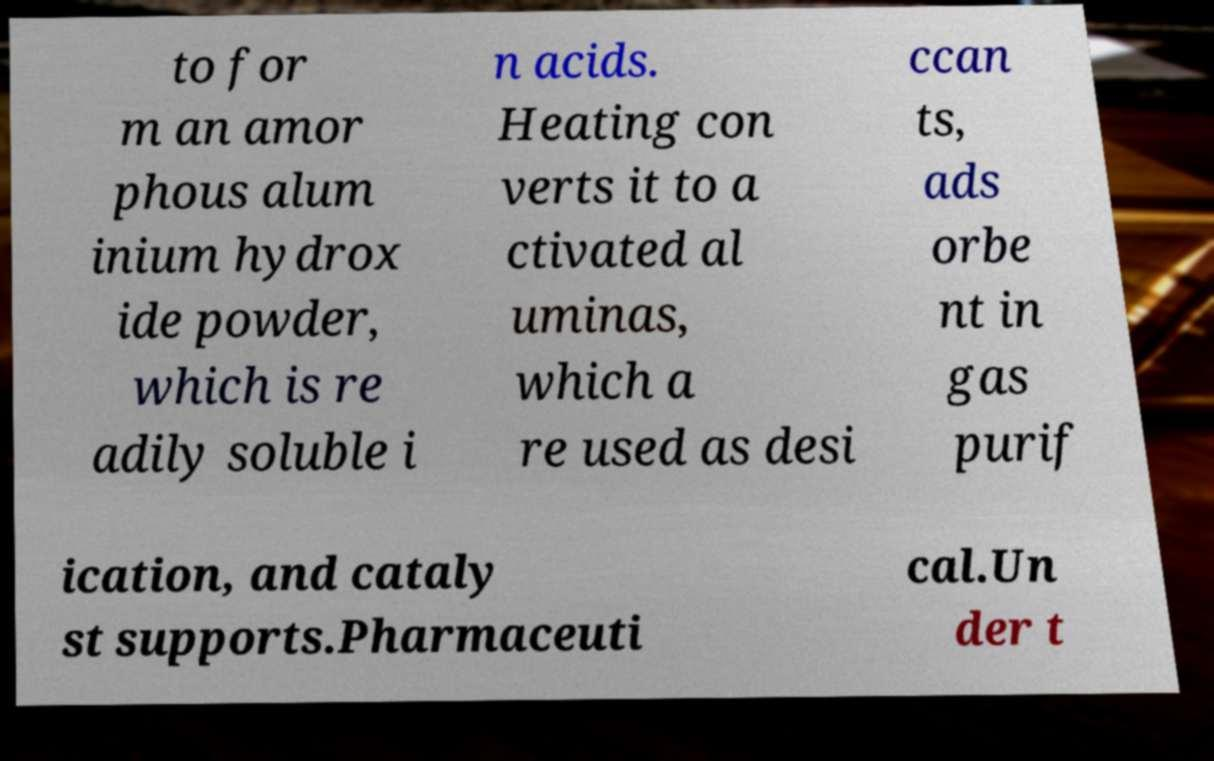Please identify and transcribe the text found in this image. to for m an amor phous alum inium hydrox ide powder, which is re adily soluble i n acids. Heating con verts it to a ctivated al uminas, which a re used as desi ccan ts, ads orbe nt in gas purif ication, and cataly st supports.Pharmaceuti cal.Un der t 